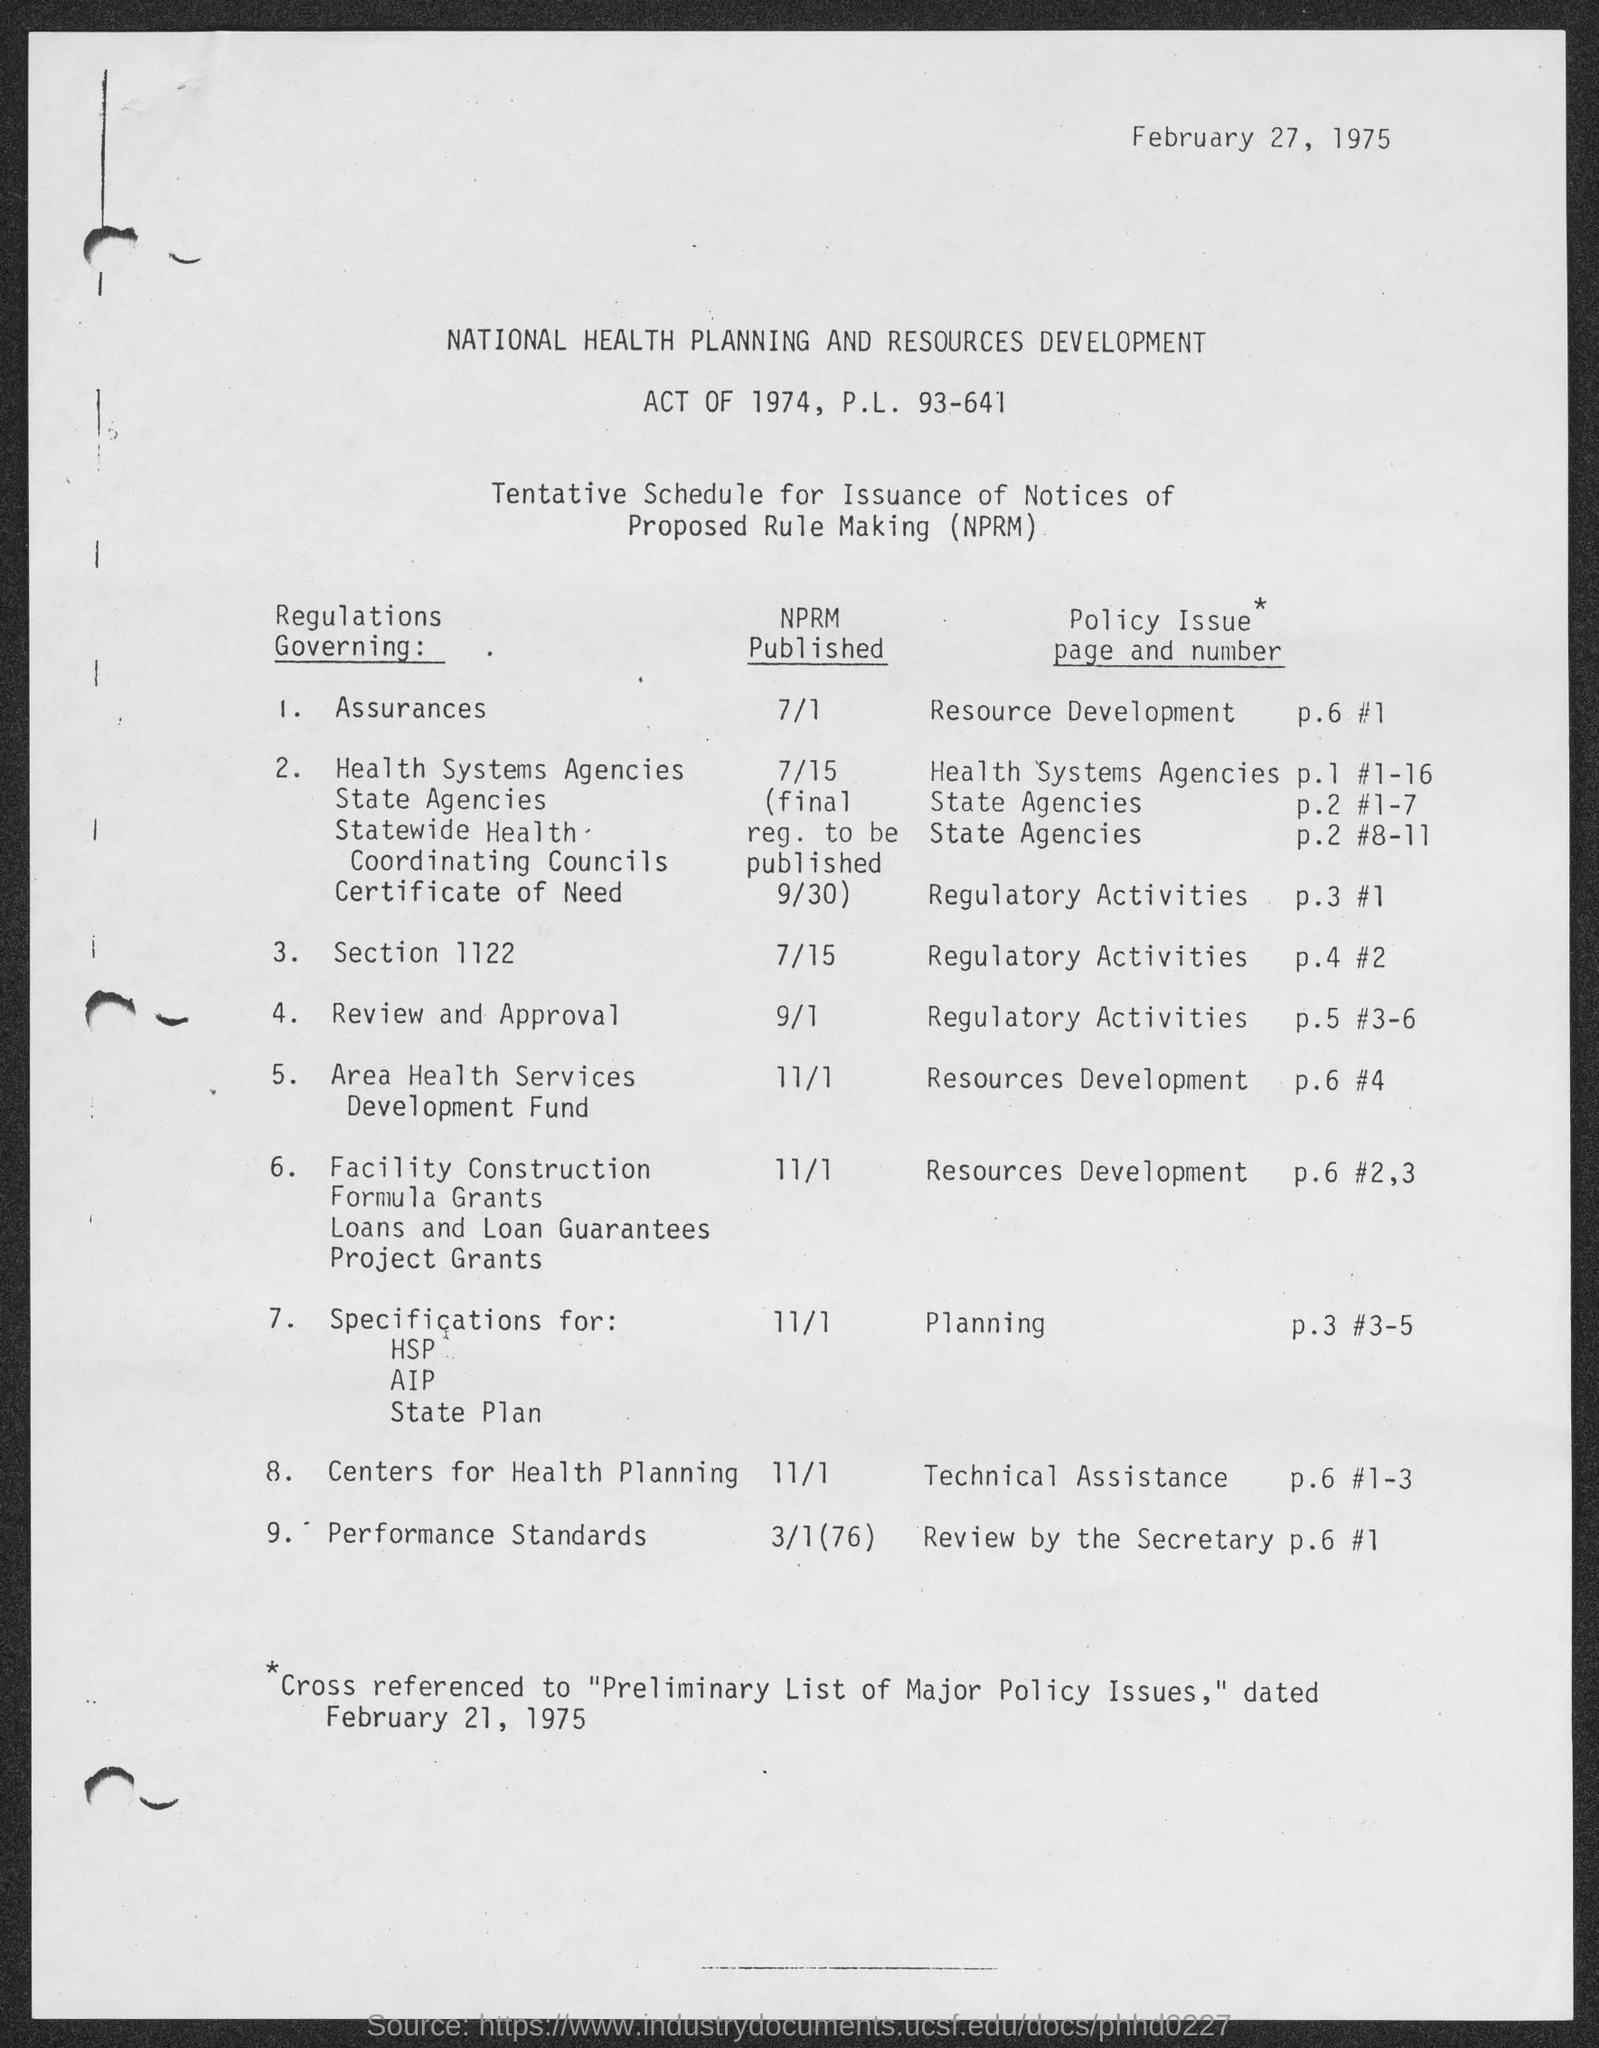Highlight a few significant elements in this photo. The NPRM for the Regulations governing assurances will be published on July 1st. The National Performance Regulations for performance standards will be published in a Notice of Proposed Rulemaking (NPRM) on March 1, 2027. The Policy Issue Page and Number for review by the secretary is page 6, item 1. The Policy Issue page and number for Technical Assistance is page 6, number 1-3. The Policy Issue Page and Number for Planning is page 3, number 3-5. 